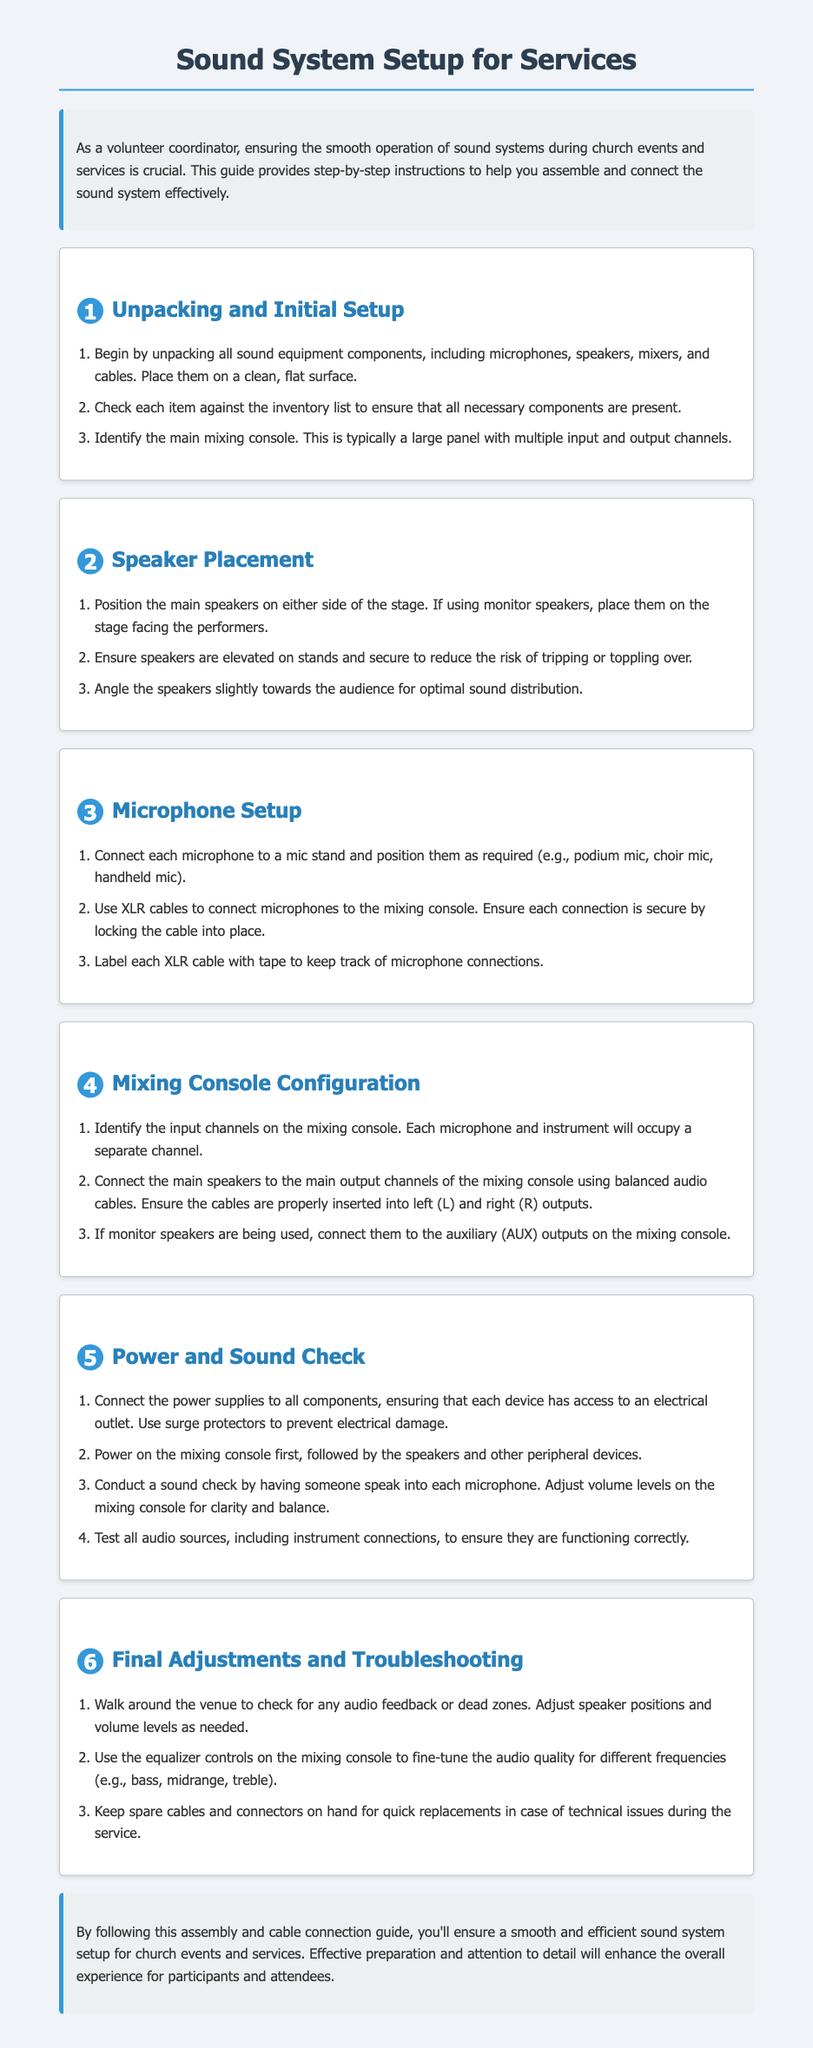what is the title of the document? The title of the document is stated at the top of the rendered document.
Answer: Sound System Setup for Services how many main steps are there for sound system setup? The main steps are numbered in the document, showing a total of six sections.
Answer: 6 what type of cables are used to connect microphones to the mixing console? The document specifies the type of cables to be used for this connection.
Answer: XLR cables where should the main speakers be positioned? The document specifies initial speaker placement in relation to the stage.
Answer: On either side of the stage what should be done first when powering on the sound system? There is a sequence for powering on components described in the document.
Answer: Mixing console what is the purpose of labeling XLR cables? The document provides reasons for this particular task as part of the microphone setup.
Answer: To keep track of microphone connections what should be kept on hand for quick replacements? This is mentioned in the final adjustments and troubleshooting section of the document.
Answer: Spare cables and connectors where should the auxiliary outputs be connected? This connection detail is provided in the mixing console configuration section.
Answer: Monitor speakers 